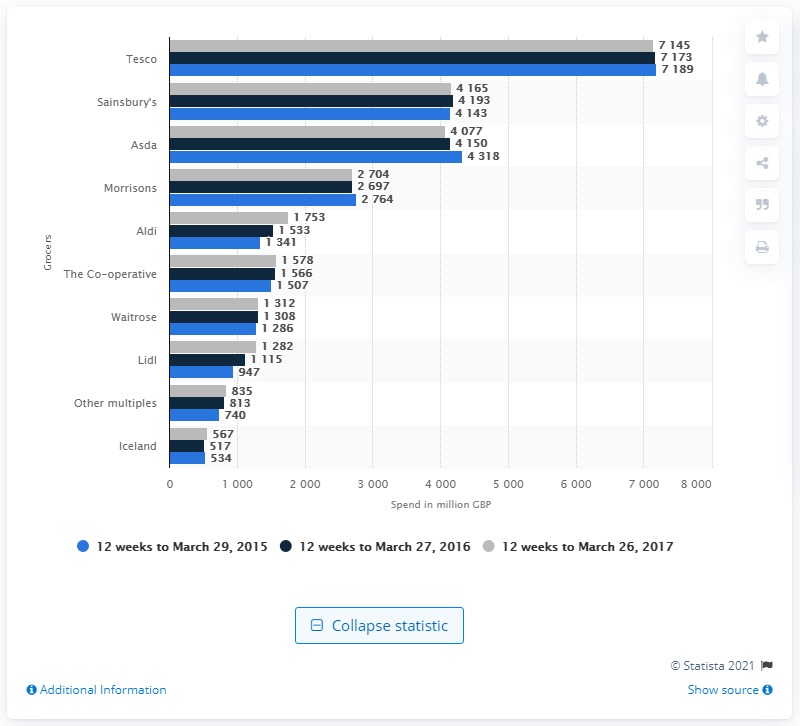Specify some key components in this picture. The total consumer expenditure in Tesco's stores for the 12-week period ending March 26th, 2017 was £7145. 